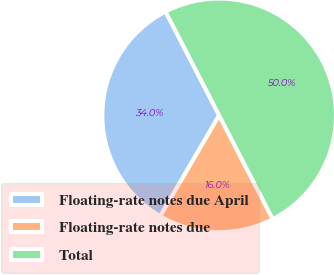Convert chart to OTSL. <chart><loc_0><loc_0><loc_500><loc_500><pie_chart><fcel>Floating-rate notes due April<fcel>Floating-rate notes due<fcel>Total<nl><fcel>34.0%<fcel>16.0%<fcel>50.0%<nl></chart> 